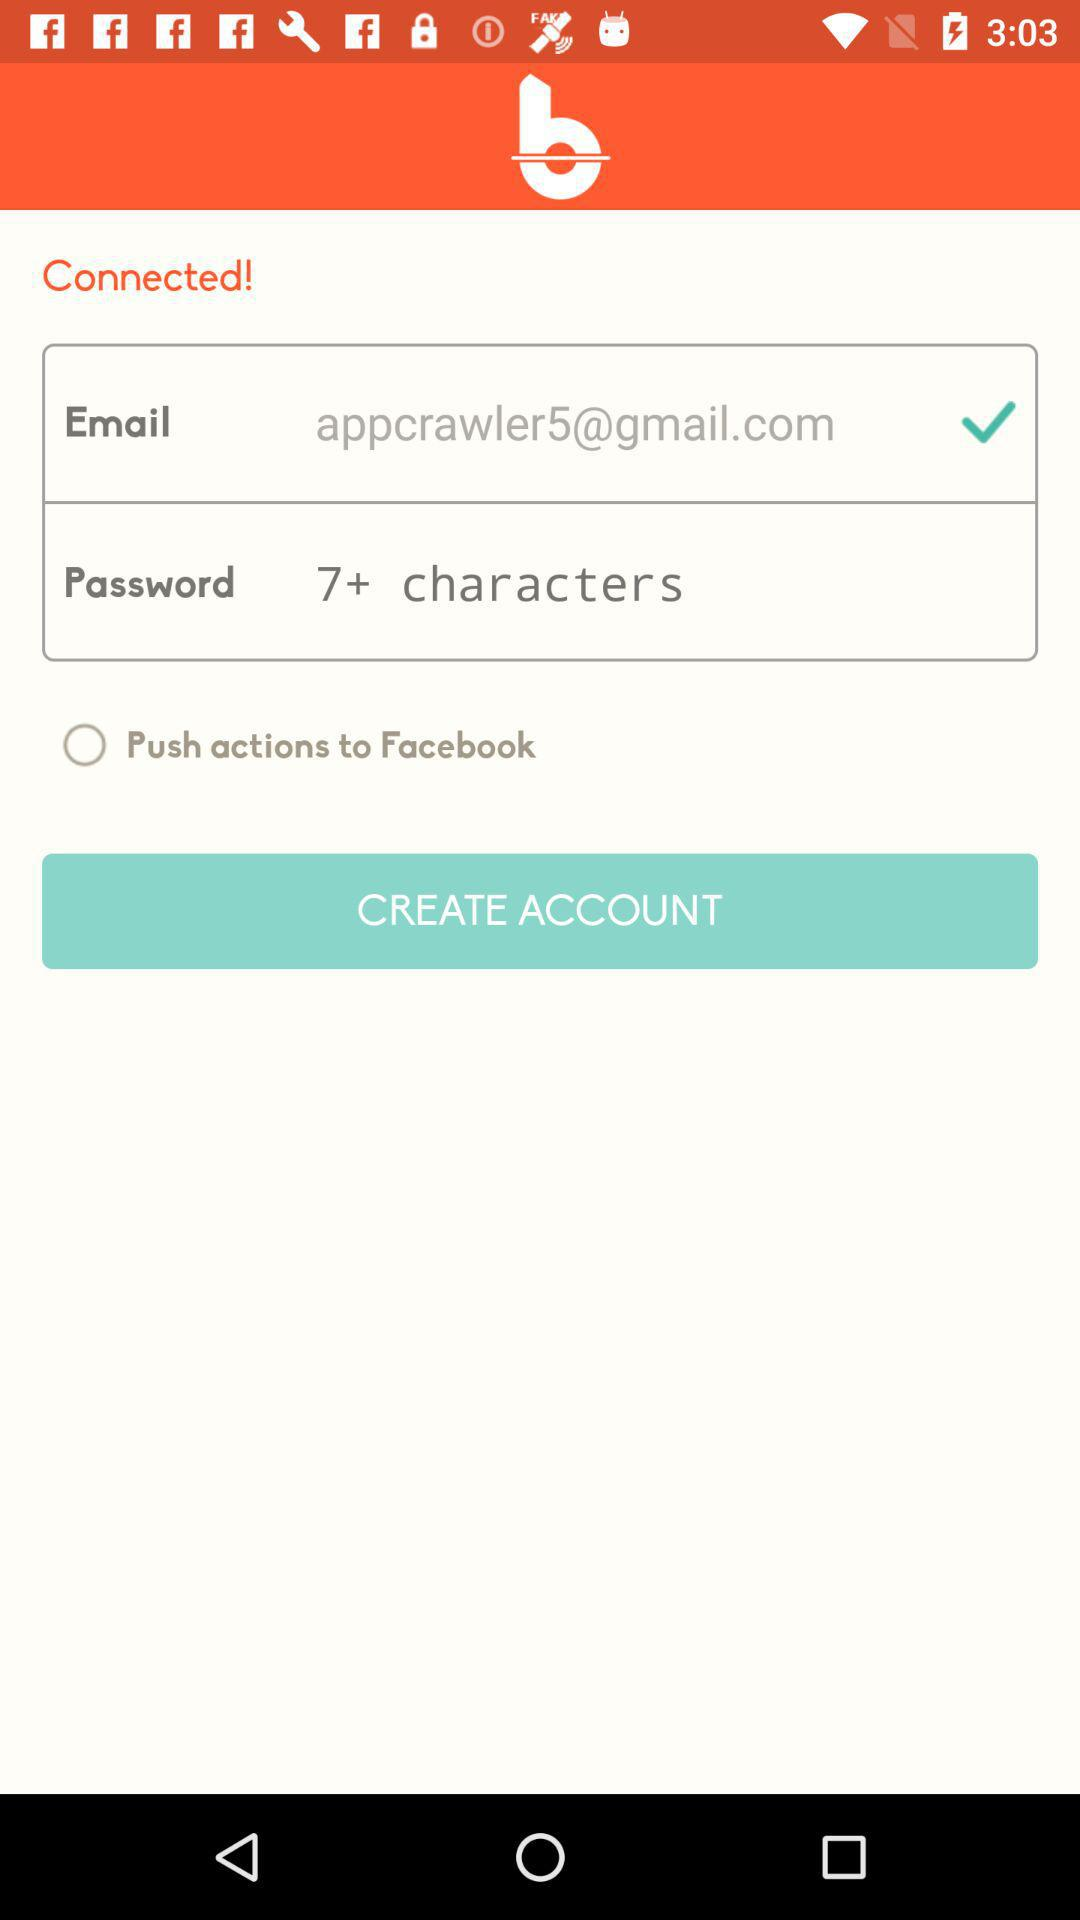What is the status of "Push actions to Facebook"? The status is "off". 